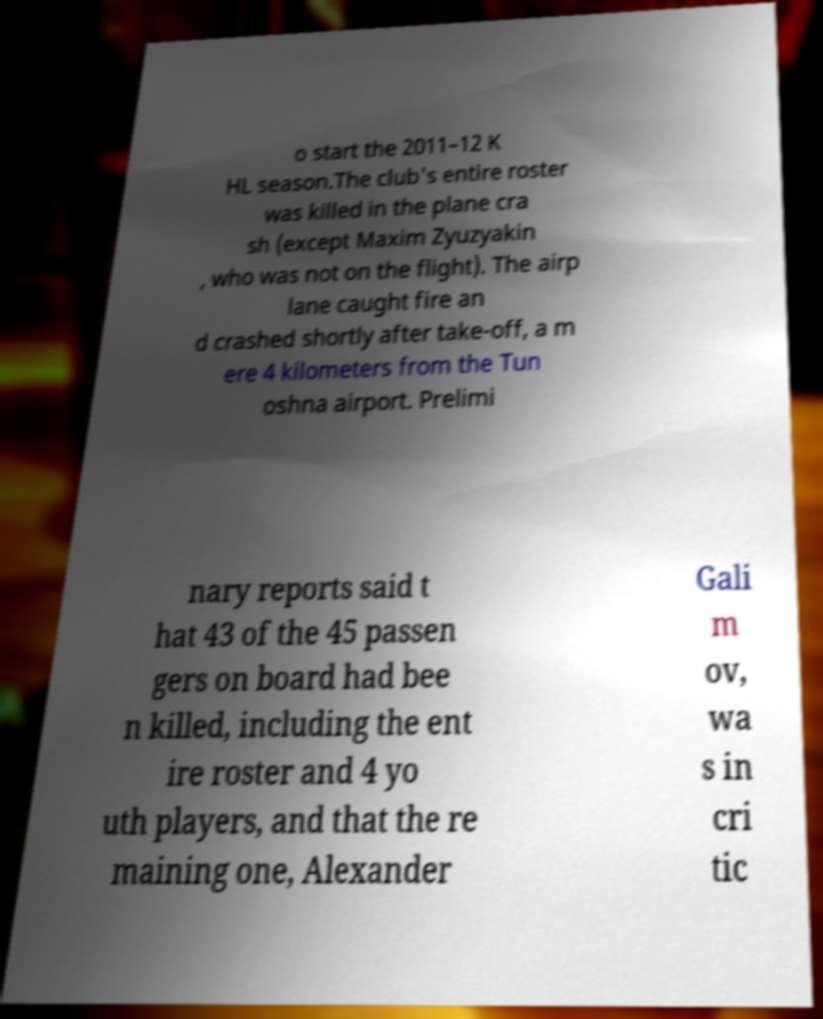Can you accurately transcribe the text from the provided image for me? o start the 2011–12 K HL season.The club's entire roster was killed in the plane cra sh (except Maxim Zyuzyakin , who was not on the flight). The airp lane caught fire an d crashed shortly after take-off, a m ere 4 kilometers from the Tun oshna airport. Prelimi nary reports said t hat 43 of the 45 passen gers on board had bee n killed, including the ent ire roster and 4 yo uth players, and that the re maining one, Alexander Gali m ov, wa s in cri tic 